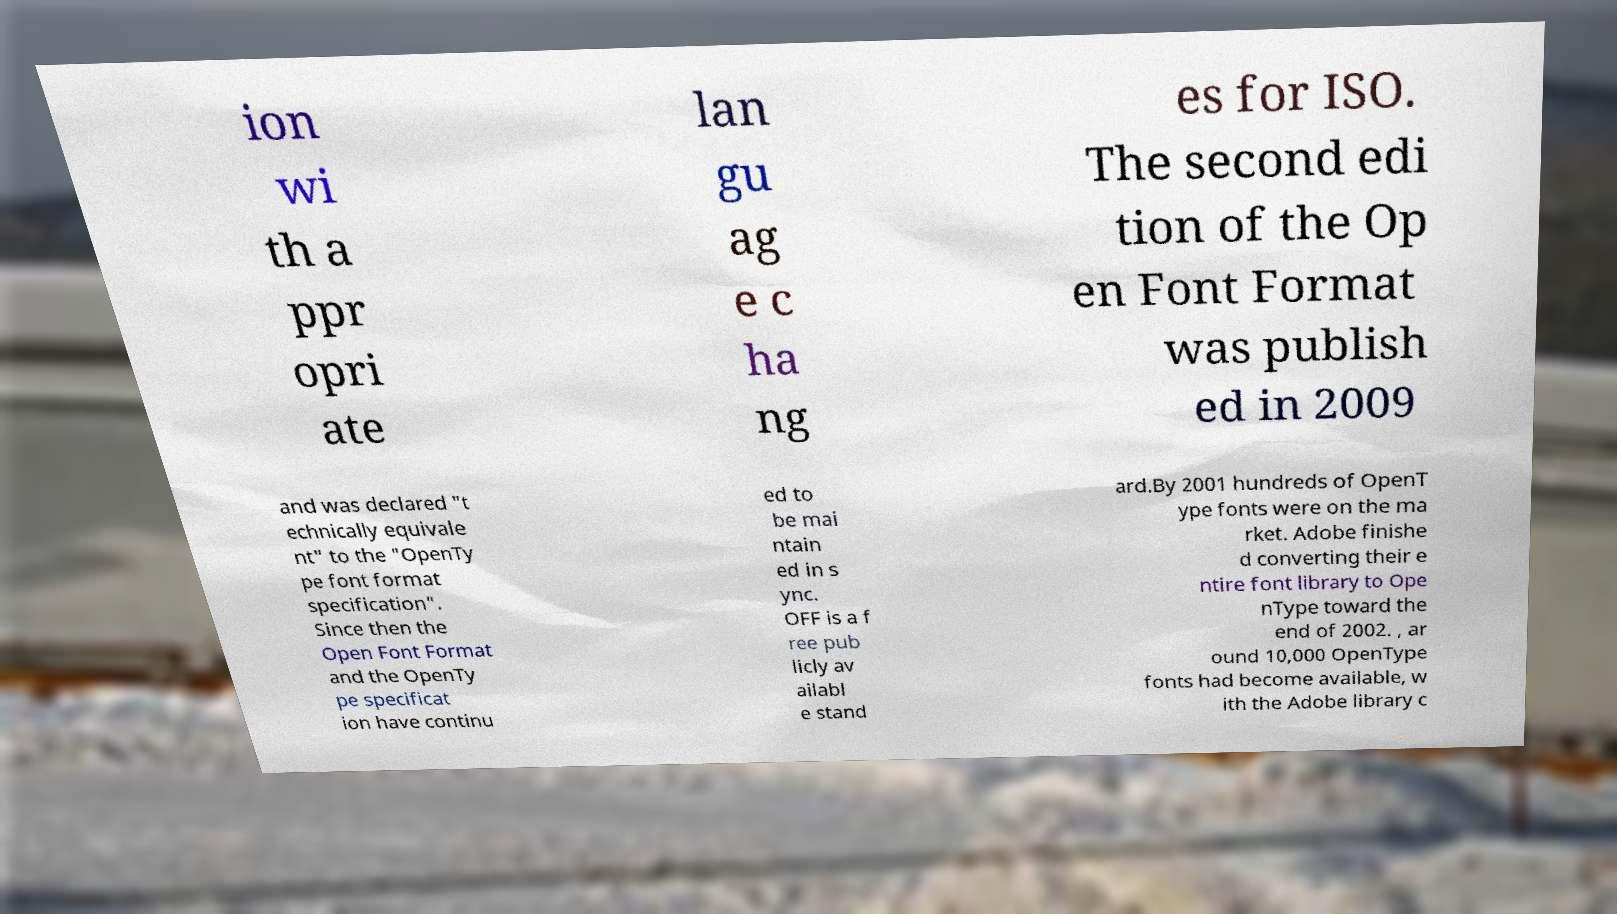For documentation purposes, I need the text within this image transcribed. Could you provide that? ion wi th a ppr opri ate lan gu ag e c ha ng es for ISO. The second edi tion of the Op en Font Format was publish ed in 2009 and was declared "t echnically equivale nt" to the "OpenTy pe font format specification". Since then the Open Font Format and the OpenTy pe specificat ion have continu ed to be mai ntain ed in s ync. OFF is a f ree pub licly av ailabl e stand ard.By 2001 hundreds of OpenT ype fonts were on the ma rket. Adobe finishe d converting their e ntire font library to Ope nType toward the end of 2002. , ar ound 10,000 OpenType fonts had become available, w ith the Adobe library c 